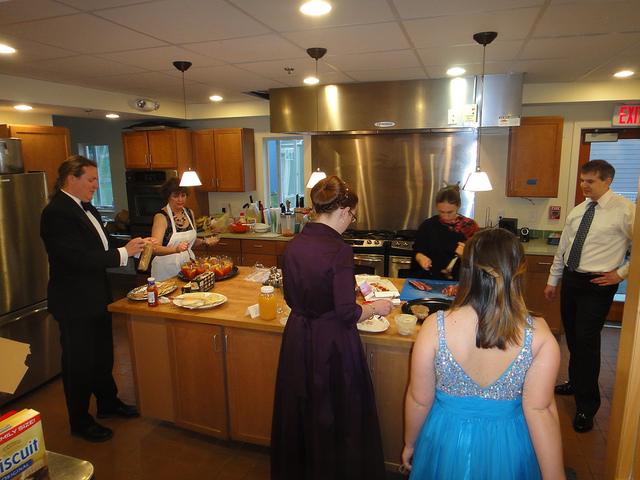<image>How many squares are there on the ceiling? I am not sure how many squares are there on the ceiling. It can be multiple. How many squares are there on the ceiling? There is no sure answer to the question. There can be multiple squares on the ceiling, but the exact number is unknown. 